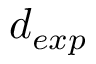<formula> <loc_0><loc_0><loc_500><loc_500>d _ { e x p }</formula> 